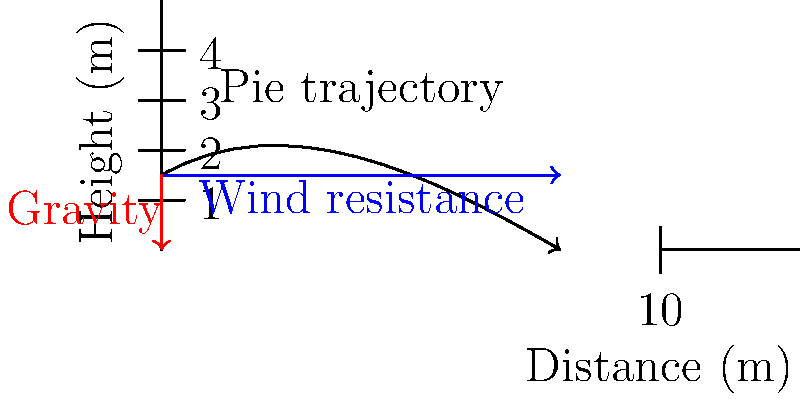You're about to deliver the punchline of your best joke when a heckler decides to throw a cream pie at you. The pie is thrown from a height of 1.5 meters with an initial velocity of 10 m/s at a 30° angle above the horizontal. If the wind resistance acts as a constant horizontal force of 2 N opposite to the pie's motion, and the pie has a mass of 0.5 kg, how far horizontally will the pie travel before it hits you in the face? (Assume g = 9.8 m/s²) Let's approach this step-by-step:

1) First, we need to break down the motion into horizontal and vertical components.

2) For the horizontal motion:
   - Initial velocity (x-component): $v_{x0} = 10 \cos(30°) = 8.66$ m/s
   - Acceleration due to wind resistance: $a_x = F/m = 2/0.5 = 4$ m/s²

3) For the vertical motion:
   - Initial velocity (y-component): $v_{y0} = 10 \sin(30°) = 5$ m/s
   - Acceleration due to gravity: $a_y = -9.8$ m/s²

4) We need to find the time it takes for the pie to hit your face. This occurs when y = 0.
   Using the equation: $y = y_0 + v_{y0}t + \frac{1}{2}a_yt^2$
   $0 = 1.5 + 5t - 4.9t^2$

5) Solving this quadratic equation:
   $t = \frac{5 \pm \sqrt{25 + 4(4.9)(1.5)}}{9.8} = 0.816$ seconds (positive root)

6) Now we can use this time to calculate the horizontal distance:
   $x = v_{x0}t - \frac{1}{2}a_xt^2$
   $x = 8.66(0.816) - \frac{1}{2}(4)(0.816)^2$
   $x = 7.07 - 1.33 = 5.74$ meters

Therefore, the pie will travel approximately 5.74 meters horizontally before hitting your face.
Answer: 5.74 meters 